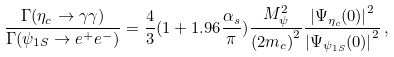Convert formula to latex. <formula><loc_0><loc_0><loc_500><loc_500>\frac { \Gamma ( \eta _ { c } \rightarrow \gamma \gamma ) } { \Gamma ( \psi _ { 1 S } \rightarrow e ^ { + } e ^ { - } ) } = \frac { 4 } { 3 } ( 1 + 1 . 9 6 \frac { \alpha _ { s } } { \pi } ) \frac { M _ { \psi } ^ { 2 } } { { ( 2 m _ { c } ) } ^ { 2 } } \frac { { | \Psi _ { \eta _ { c } } ( 0 ) | } ^ { 2 } } { { | \Psi _ { \psi _ { 1 S } } ( 0 ) | } ^ { 2 } } \, ,</formula> 